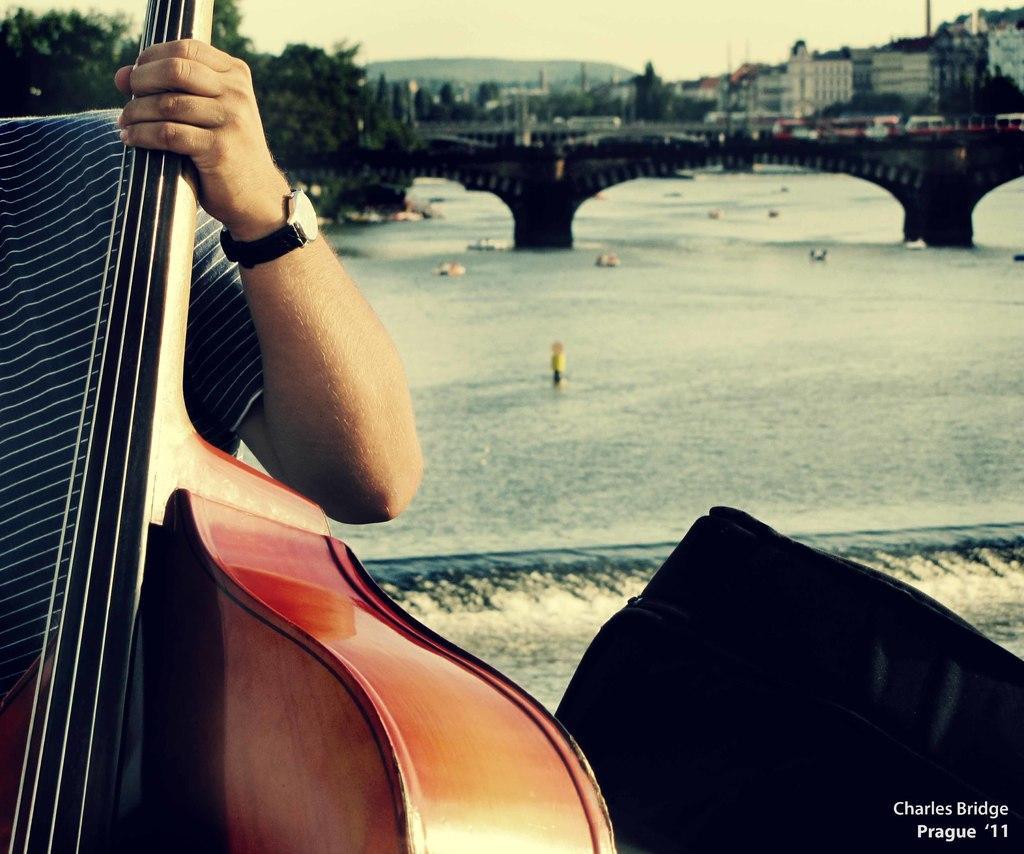Can you describe this image briefly? Here we can see a person holding the guitar in his hands, and at back here is the water, and here is the bridge, and here are the buildings. 